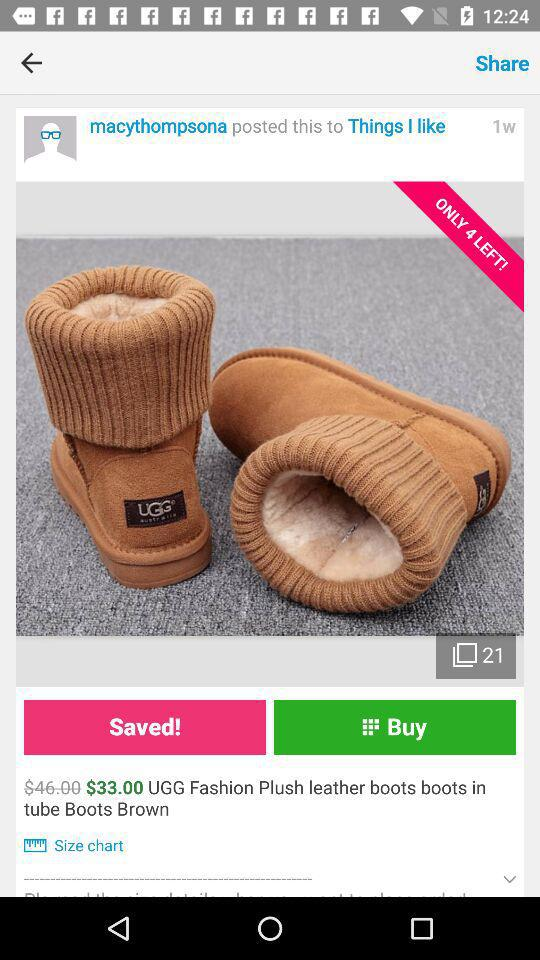What size are the boots?
When the provided information is insufficient, respond with <no answer>. <no answer> 